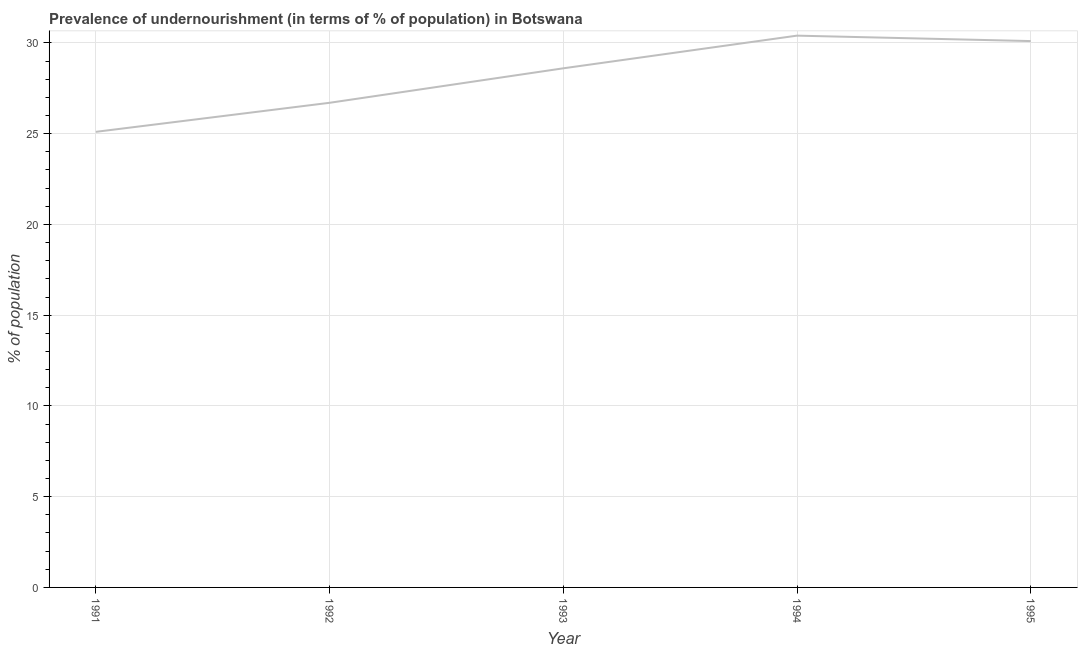What is the percentage of undernourished population in 1994?
Your answer should be very brief. 30.4. Across all years, what is the maximum percentage of undernourished population?
Offer a very short reply. 30.4. Across all years, what is the minimum percentage of undernourished population?
Provide a succinct answer. 25.1. In which year was the percentage of undernourished population maximum?
Your answer should be compact. 1994. What is the sum of the percentage of undernourished population?
Your answer should be compact. 140.9. What is the difference between the percentage of undernourished population in 1992 and 1995?
Keep it short and to the point. -3.4. What is the average percentage of undernourished population per year?
Your response must be concise. 28.18. What is the median percentage of undernourished population?
Give a very brief answer. 28.6. In how many years, is the percentage of undernourished population greater than 2 %?
Give a very brief answer. 5. What is the ratio of the percentage of undernourished population in 1991 to that in 1993?
Provide a short and direct response. 0.88. What is the difference between the highest and the second highest percentage of undernourished population?
Keep it short and to the point. 0.3. Is the sum of the percentage of undernourished population in 1991 and 1995 greater than the maximum percentage of undernourished population across all years?
Provide a short and direct response. Yes. What is the difference between the highest and the lowest percentage of undernourished population?
Keep it short and to the point. 5.3. In how many years, is the percentage of undernourished population greater than the average percentage of undernourished population taken over all years?
Make the answer very short. 3. How many lines are there?
Your answer should be compact. 1. What is the difference between two consecutive major ticks on the Y-axis?
Your answer should be very brief. 5. Does the graph contain grids?
Make the answer very short. Yes. What is the title of the graph?
Ensure brevity in your answer.  Prevalence of undernourishment (in terms of % of population) in Botswana. What is the label or title of the X-axis?
Make the answer very short. Year. What is the label or title of the Y-axis?
Your answer should be compact. % of population. What is the % of population of 1991?
Keep it short and to the point. 25.1. What is the % of population of 1992?
Offer a terse response. 26.7. What is the % of population in 1993?
Provide a succinct answer. 28.6. What is the % of population of 1994?
Keep it short and to the point. 30.4. What is the % of population in 1995?
Keep it short and to the point. 30.1. What is the difference between the % of population in 1991 and 1993?
Your response must be concise. -3.5. What is the difference between the % of population in 1991 and 1994?
Give a very brief answer. -5.3. What is the difference between the % of population in 1992 and 1993?
Your response must be concise. -1.9. What is the difference between the % of population in 1993 and 1995?
Keep it short and to the point. -1.5. What is the ratio of the % of population in 1991 to that in 1992?
Provide a succinct answer. 0.94. What is the ratio of the % of population in 1991 to that in 1993?
Make the answer very short. 0.88. What is the ratio of the % of population in 1991 to that in 1994?
Make the answer very short. 0.83. What is the ratio of the % of population in 1991 to that in 1995?
Your answer should be very brief. 0.83. What is the ratio of the % of population in 1992 to that in 1993?
Make the answer very short. 0.93. What is the ratio of the % of population in 1992 to that in 1994?
Ensure brevity in your answer.  0.88. What is the ratio of the % of population in 1992 to that in 1995?
Your response must be concise. 0.89. What is the ratio of the % of population in 1993 to that in 1994?
Offer a very short reply. 0.94. What is the ratio of the % of population in 1993 to that in 1995?
Keep it short and to the point. 0.95. 